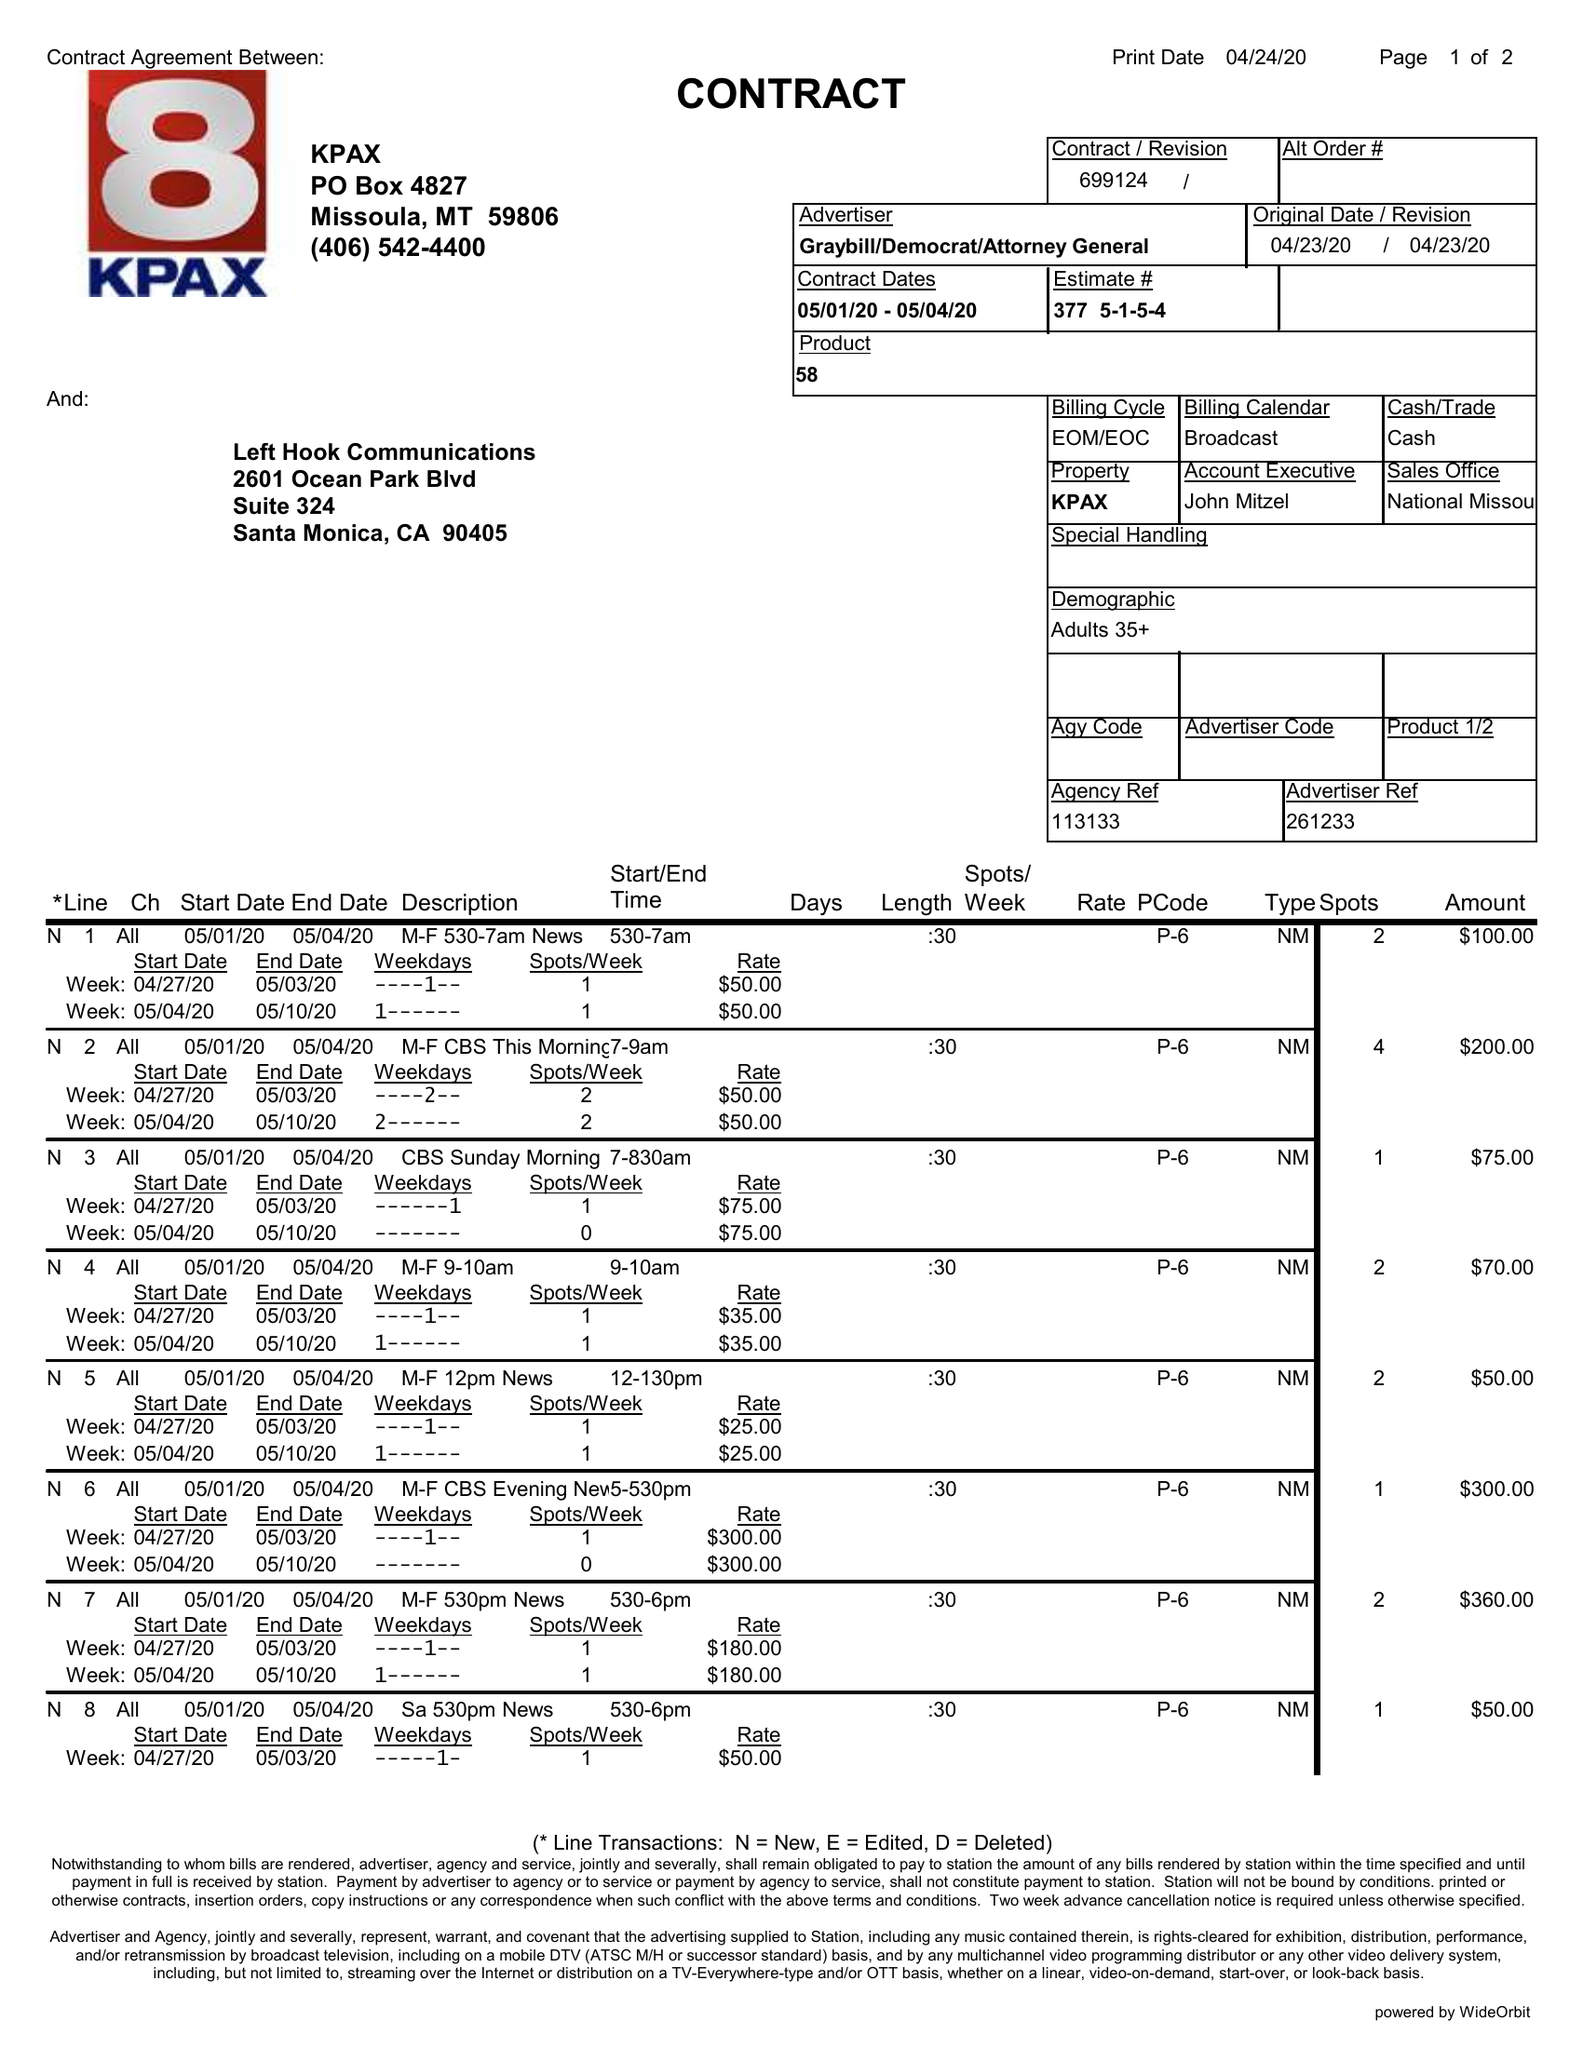What is the value for the contract_num?
Answer the question using a single word or phrase. 699124 